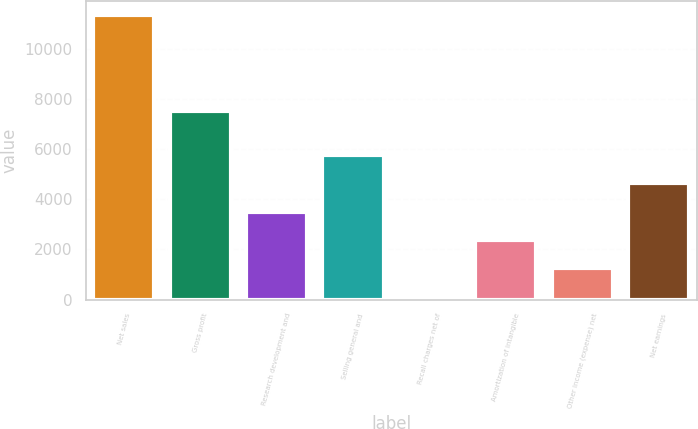<chart> <loc_0><loc_0><loc_500><loc_500><bar_chart><fcel>Net sales<fcel>Gross profit<fcel>Research development and<fcel>Selling general and<fcel>Recall charges net of<fcel>Amortization of intangible<fcel>Other income (expense) net<fcel>Net earnings<nl><fcel>11325<fcel>7495<fcel>3508.1<fcel>5741.5<fcel>158<fcel>2391.4<fcel>1274.7<fcel>4624.8<nl></chart> 